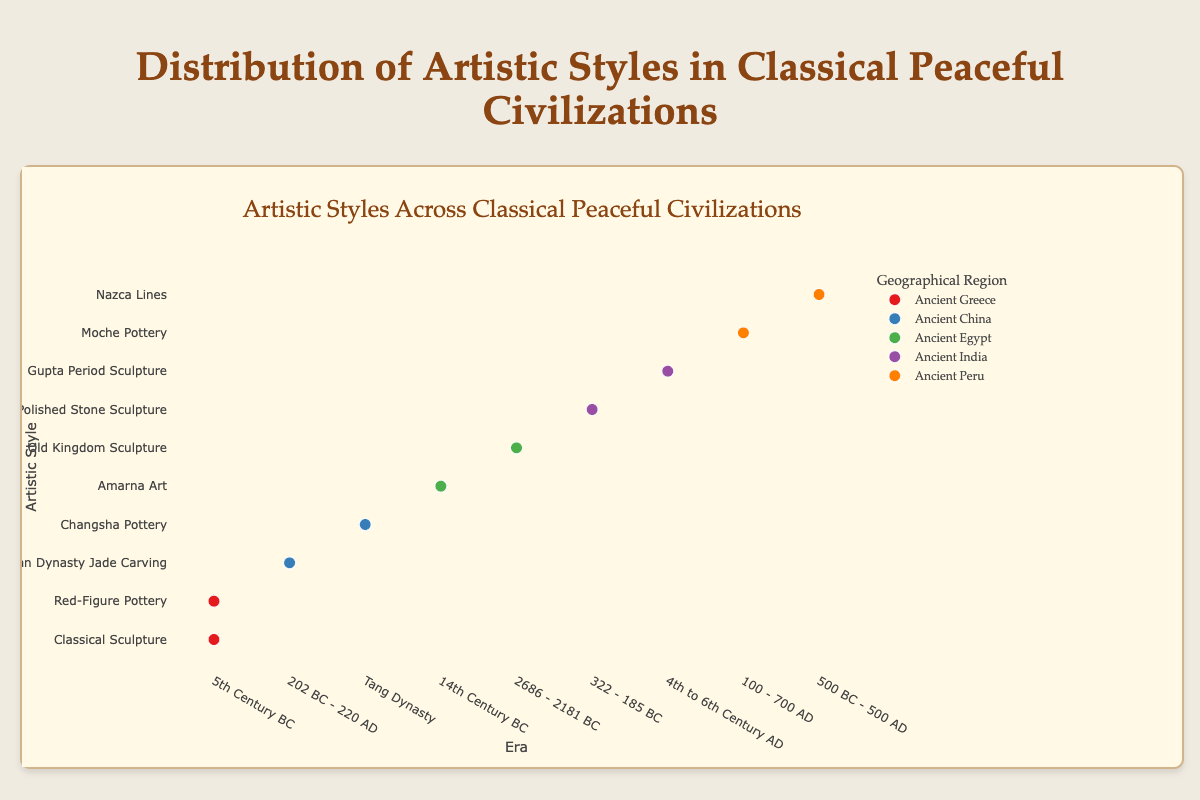What is the title of the plot? The title of the plot is centered at the top and reads "Artistic Styles Across Classical Peaceful Civilizations".
Answer: Artistic Styles Across Classical Peaceful Civilizations How many artistic styles are depicted in the Ancient Greece region? From the figure, the Ancient Greece region has two distinct data points representing two artistic styles: "Classical Sculpture" and "Red-Figure Pottery".
Answer: 2 Which geographical region has the artistic style "Amarna Art"? In the y-axis, "Amarna Art" lines up with "Ancient Egypt" in the grouped data points.
Answer: Ancient Egypt What is the era of the "Han Dynasty Jade Carving" style? The text associated with the "Han Dynasty Jade Carving" artistic style indicates that it is from "202 BC - 220 AD".
Answer: 202 BC - 220 AD Which region has the most artistic styles represented, and what are they? By counting the data points across all geographical regions, Ancient Greece, Ancient China, Ancient Egypt, and Ancient India each have two data points. However, Ancient Peru also has two distinct artistic styles: "Moche Pottery" and "Nazca Lines". Therefore, they all equally have the most artistic styles represented.
Answer: Ancient Greece, Ancient China, Ancient Egypt, Ancient India, Ancient Peru Compare the era of "Old Kingdom Sculpture" to "Changsha Pottery". Which is older? "Old Kingdom Sculpture" (2686 - 2181 BC) belongs to a much earlier period compared to "Changsha Pottery" of the Tang Dynasty. Thus, "Old Kingdom Sculpture" is older.
Answer: Old Kingdom Sculpture Which artistic styles include notable artworks created by known prominent artists? By examining the hover text details, "Classical Sculpture" by Phidias and Myron, "Red-Figure Pottery" by Euphronios and Euthymides, and "Amarna Art" by Thutmose have known prominent artists.
Answer: Classical Sculpture, Red-Figure Pottery, Amarna Art What common characteristics can be observed between artistic styles of Ancient India? Hovering over the data points for Ancient Indian artistic styles shows that "Mauryan Polished Stone Sculpture" and "Gupta Period Sculpture" both emphasize religious or symbolic import and refinement.
Answer: Highly Polished Surface, Symbolic Import, Buddhist Themes (Mauryan); Graceful Proportions, Serene Expressions, Religious Motifs (Gupta) How many distinct colors are used to represent different geographical regions in the plot? Inspecting the legend and the data points reveals five distinct colors corresponding to the regions represented.
Answer: 5 